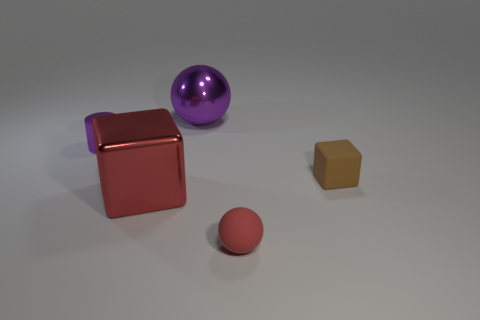Is there any other thing that has the same size as the cylinder?
Provide a short and direct response. Yes. Is there a big metallic thing of the same color as the tiny cylinder?
Make the answer very short. Yes. There is a tiny object to the left of the large purple metallic ball; is its color the same as the large sphere?
Your answer should be compact. Yes. Is there any other thing that is the same color as the small cube?
Ensure brevity in your answer.  No. Is the material of the big red thing the same as the sphere in front of the tiny purple metallic thing?
Provide a succinct answer. No. There is a big shiny thing behind the small matte thing that is right of the red ball; what is its shape?
Offer a very short reply. Sphere. What is the shape of the small object that is both to the right of the purple cylinder and behind the red matte object?
Provide a short and direct response. Cube. What number of objects are either brown cubes or things in front of the metallic ball?
Keep it short and to the point. 4. There is a large red thing that is the same shape as the tiny brown object; what is its material?
Make the answer very short. Metal. There is a object that is in front of the purple cylinder and to the left of the red rubber object; what material is it?
Offer a very short reply. Metal. 